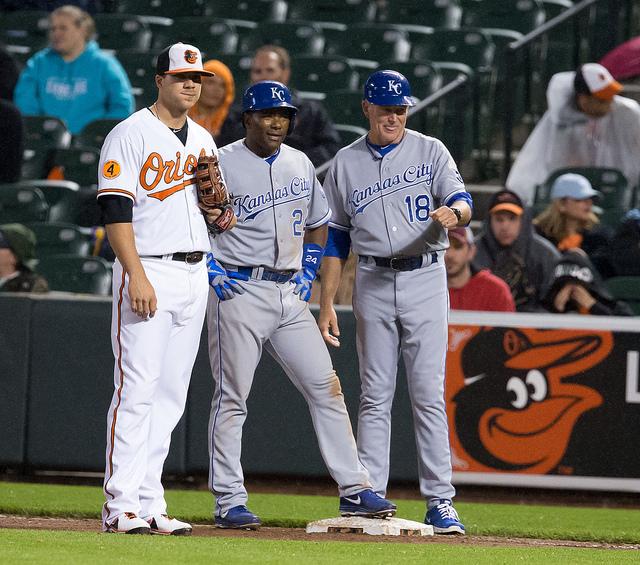What team is the player in white on?
Give a very brief answer. Orioles. Does the fan have a hat on?
Write a very short answer. Yes. Which way is the fan in the clear rain poncho looking?
Be succinct. Right. Do the players look happy?
Write a very short answer. Yes. Are the men playing for the same team?
Write a very short answer. No. What kind of shoes are the player's wearing?
Concise answer only. Cleats. 